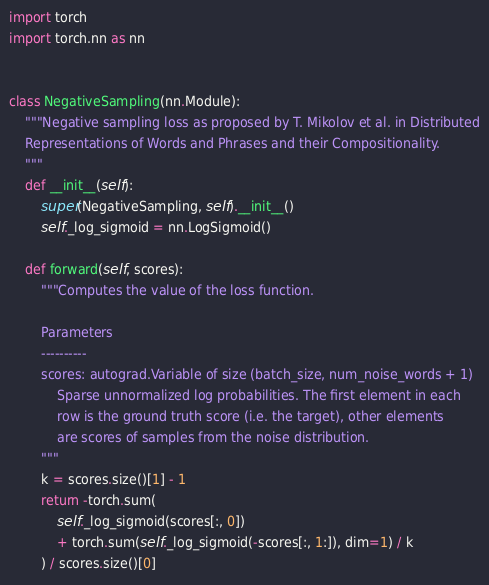<code> <loc_0><loc_0><loc_500><loc_500><_Python_>import torch
import torch.nn as nn


class NegativeSampling(nn.Module):
    """Negative sampling loss as proposed by T. Mikolov et al. in Distributed
    Representations of Words and Phrases and their Compositionality.
    """
    def __init__(self):
        super(NegativeSampling, self).__init__()
        self._log_sigmoid = nn.LogSigmoid()

    def forward(self, scores):
        """Computes the value of the loss function.

        Parameters
        ----------
        scores: autograd.Variable of size (batch_size, num_noise_words + 1)
            Sparse unnormalized log probabilities. The first element in each
            row is the ground truth score (i.e. the target), other elements
            are scores of samples from the noise distribution.
        """
        k = scores.size()[1] - 1
        return -torch.sum(
            self._log_sigmoid(scores[:, 0])
            + torch.sum(self._log_sigmoid(-scores[:, 1:]), dim=1) / k
        ) / scores.size()[0]
</code> 